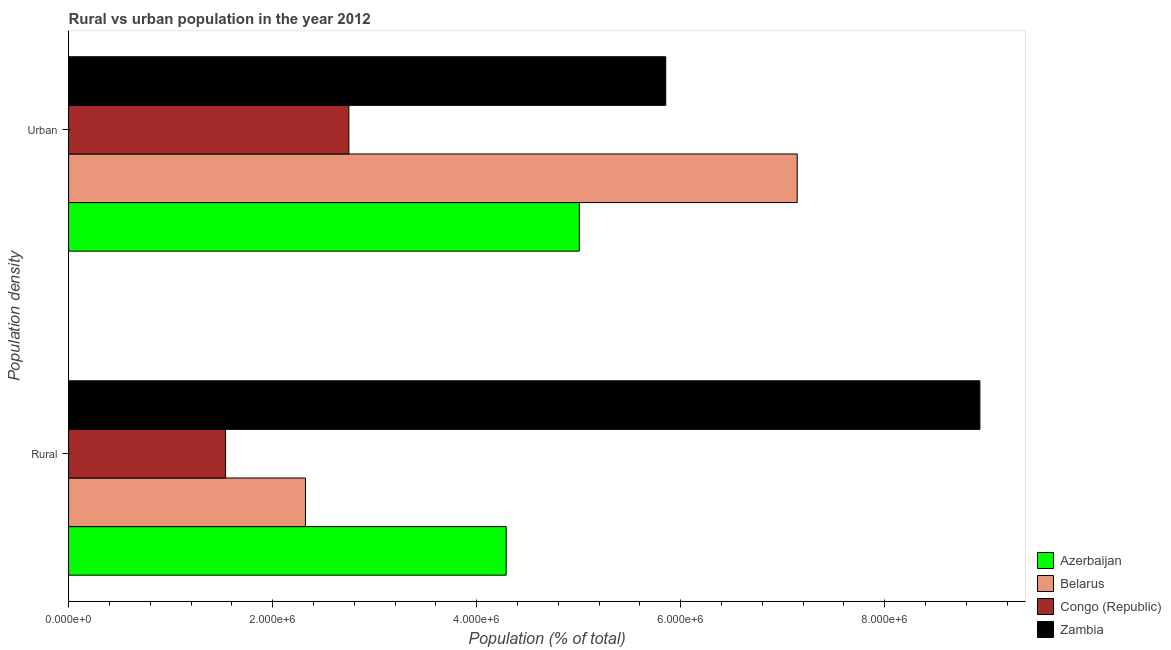How many different coloured bars are there?
Provide a short and direct response. 4. How many bars are there on the 1st tick from the bottom?
Offer a very short reply. 4. What is the label of the 2nd group of bars from the top?
Provide a succinct answer. Rural. What is the urban population density in Belarus?
Ensure brevity in your answer.  7.14e+06. Across all countries, what is the maximum urban population density?
Offer a very short reply. 7.14e+06. Across all countries, what is the minimum rural population density?
Your answer should be very brief. 1.54e+06. In which country was the rural population density maximum?
Ensure brevity in your answer.  Zambia. In which country was the rural population density minimum?
Offer a terse response. Congo (Republic). What is the total rural population density in the graph?
Make the answer very short. 1.71e+07. What is the difference between the urban population density in Zambia and that in Congo (Republic)?
Your answer should be compact. 3.11e+06. What is the difference between the rural population density in Zambia and the urban population density in Congo (Republic)?
Make the answer very short. 6.19e+06. What is the average rural population density per country?
Make the answer very short. 4.27e+06. What is the difference between the rural population density and urban population density in Belarus?
Keep it short and to the point. -4.82e+06. What is the ratio of the rural population density in Zambia to that in Belarus?
Ensure brevity in your answer.  3.85. What does the 4th bar from the top in Urban represents?
Provide a succinct answer. Azerbaijan. What does the 4th bar from the bottom in Urban represents?
Give a very brief answer. Zambia. Are all the bars in the graph horizontal?
Your answer should be compact. Yes. How many countries are there in the graph?
Keep it short and to the point. 4. What is the difference between two consecutive major ticks on the X-axis?
Your answer should be compact. 2.00e+06. Does the graph contain any zero values?
Offer a terse response. No. Does the graph contain grids?
Offer a very short reply. No. Where does the legend appear in the graph?
Give a very brief answer. Bottom right. How many legend labels are there?
Offer a very short reply. 4. What is the title of the graph?
Your response must be concise. Rural vs urban population in the year 2012. Does "Yemen, Rep." appear as one of the legend labels in the graph?
Your answer should be very brief. No. What is the label or title of the X-axis?
Your answer should be compact. Population (% of total). What is the label or title of the Y-axis?
Keep it short and to the point. Population density. What is the Population (% of total) of Azerbaijan in Rural?
Give a very brief answer. 4.29e+06. What is the Population (% of total) in Belarus in Rural?
Offer a terse response. 2.32e+06. What is the Population (% of total) in Congo (Republic) in Rural?
Your answer should be compact. 1.54e+06. What is the Population (% of total) in Zambia in Rural?
Offer a very short reply. 8.93e+06. What is the Population (% of total) of Azerbaijan in Urban?
Ensure brevity in your answer.  5.01e+06. What is the Population (% of total) of Belarus in Urban?
Offer a very short reply. 7.14e+06. What is the Population (% of total) in Congo (Republic) in Urban?
Your response must be concise. 2.75e+06. What is the Population (% of total) of Zambia in Urban?
Your answer should be very brief. 5.85e+06. Across all Population density, what is the maximum Population (% of total) of Azerbaijan?
Make the answer very short. 5.01e+06. Across all Population density, what is the maximum Population (% of total) of Belarus?
Your response must be concise. 7.14e+06. Across all Population density, what is the maximum Population (% of total) in Congo (Republic)?
Offer a terse response. 2.75e+06. Across all Population density, what is the maximum Population (% of total) in Zambia?
Your answer should be compact. 8.93e+06. Across all Population density, what is the minimum Population (% of total) of Azerbaijan?
Make the answer very short. 4.29e+06. Across all Population density, what is the minimum Population (% of total) in Belarus?
Ensure brevity in your answer.  2.32e+06. Across all Population density, what is the minimum Population (% of total) in Congo (Republic)?
Ensure brevity in your answer.  1.54e+06. Across all Population density, what is the minimum Population (% of total) in Zambia?
Give a very brief answer. 5.85e+06. What is the total Population (% of total) in Azerbaijan in the graph?
Your response must be concise. 9.30e+06. What is the total Population (% of total) in Belarus in the graph?
Your answer should be compact. 9.46e+06. What is the total Population (% of total) in Congo (Republic) in the graph?
Offer a very short reply. 4.29e+06. What is the total Population (% of total) of Zambia in the graph?
Your answer should be very brief. 1.48e+07. What is the difference between the Population (% of total) in Azerbaijan in Rural and that in Urban?
Make the answer very short. -7.17e+05. What is the difference between the Population (% of total) in Belarus in Rural and that in Urban?
Offer a very short reply. -4.82e+06. What is the difference between the Population (% of total) of Congo (Republic) in Rural and that in Urban?
Keep it short and to the point. -1.21e+06. What is the difference between the Population (% of total) of Zambia in Rural and that in Urban?
Make the answer very short. 3.08e+06. What is the difference between the Population (% of total) of Azerbaijan in Rural and the Population (% of total) of Belarus in Urban?
Provide a short and direct response. -2.85e+06. What is the difference between the Population (% of total) of Azerbaijan in Rural and the Population (% of total) of Congo (Republic) in Urban?
Your answer should be compact. 1.54e+06. What is the difference between the Population (% of total) of Azerbaijan in Rural and the Population (% of total) of Zambia in Urban?
Give a very brief answer. -1.56e+06. What is the difference between the Population (% of total) of Belarus in Rural and the Population (% of total) of Congo (Republic) in Urban?
Your answer should be compact. -4.26e+05. What is the difference between the Population (% of total) in Belarus in Rural and the Population (% of total) in Zambia in Urban?
Offer a very short reply. -3.53e+06. What is the difference between the Population (% of total) in Congo (Republic) in Rural and the Population (% of total) in Zambia in Urban?
Give a very brief answer. -4.31e+06. What is the average Population (% of total) in Azerbaijan per Population density?
Ensure brevity in your answer.  4.65e+06. What is the average Population (% of total) in Belarus per Population density?
Provide a succinct answer. 4.73e+06. What is the average Population (% of total) in Congo (Republic) per Population density?
Your answer should be very brief. 2.14e+06. What is the average Population (% of total) in Zambia per Population density?
Make the answer very short. 7.39e+06. What is the difference between the Population (% of total) in Azerbaijan and Population (% of total) in Belarus in Rural?
Ensure brevity in your answer.  1.97e+06. What is the difference between the Population (% of total) of Azerbaijan and Population (% of total) of Congo (Republic) in Rural?
Your response must be concise. 2.75e+06. What is the difference between the Population (% of total) of Azerbaijan and Population (% of total) of Zambia in Rural?
Your answer should be compact. -4.64e+06. What is the difference between the Population (% of total) in Belarus and Population (% of total) in Congo (Republic) in Rural?
Your answer should be compact. 7.83e+05. What is the difference between the Population (% of total) in Belarus and Population (% of total) in Zambia in Rural?
Offer a very short reply. -6.61e+06. What is the difference between the Population (% of total) of Congo (Republic) and Population (% of total) of Zambia in Rural?
Ensure brevity in your answer.  -7.39e+06. What is the difference between the Population (% of total) of Azerbaijan and Population (% of total) of Belarus in Urban?
Make the answer very short. -2.14e+06. What is the difference between the Population (% of total) in Azerbaijan and Population (% of total) in Congo (Republic) in Urban?
Your answer should be compact. 2.26e+06. What is the difference between the Population (% of total) of Azerbaijan and Population (% of total) of Zambia in Urban?
Your response must be concise. -8.47e+05. What is the difference between the Population (% of total) in Belarus and Population (% of total) in Congo (Republic) in Urban?
Your answer should be compact. 4.39e+06. What is the difference between the Population (% of total) of Belarus and Population (% of total) of Zambia in Urban?
Make the answer very short. 1.29e+06. What is the difference between the Population (% of total) in Congo (Republic) and Population (% of total) in Zambia in Urban?
Give a very brief answer. -3.11e+06. What is the ratio of the Population (% of total) of Azerbaijan in Rural to that in Urban?
Your response must be concise. 0.86. What is the ratio of the Population (% of total) in Belarus in Rural to that in Urban?
Ensure brevity in your answer.  0.33. What is the ratio of the Population (% of total) in Congo (Republic) in Rural to that in Urban?
Keep it short and to the point. 0.56. What is the ratio of the Population (% of total) of Zambia in Rural to that in Urban?
Provide a short and direct response. 1.53. What is the difference between the highest and the second highest Population (% of total) of Azerbaijan?
Ensure brevity in your answer.  7.17e+05. What is the difference between the highest and the second highest Population (% of total) of Belarus?
Give a very brief answer. 4.82e+06. What is the difference between the highest and the second highest Population (% of total) of Congo (Republic)?
Your response must be concise. 1.21e+06. What is the difference between the highest and the second highest Population (% of total) of Zambia?
Offer a very short reply. 3.08e+06. What is the difference between the highest and the lowest Population (% of total) of Azerbaijan?
Offer a very short reply. 7.17e+05. What is the difference between the highest and the lowest Population (% of total) of Belarus?
Make the answer very short. 4.82e+06. What is the difference between the highest and the lowest Population (% of total) in Congo (Republic)?
Your response must be concise. 1.21e+06. What is the difference between the highest and the lowest Population (% of total) in Zambia?
Provide a short and direct response. 3.08e+06. 